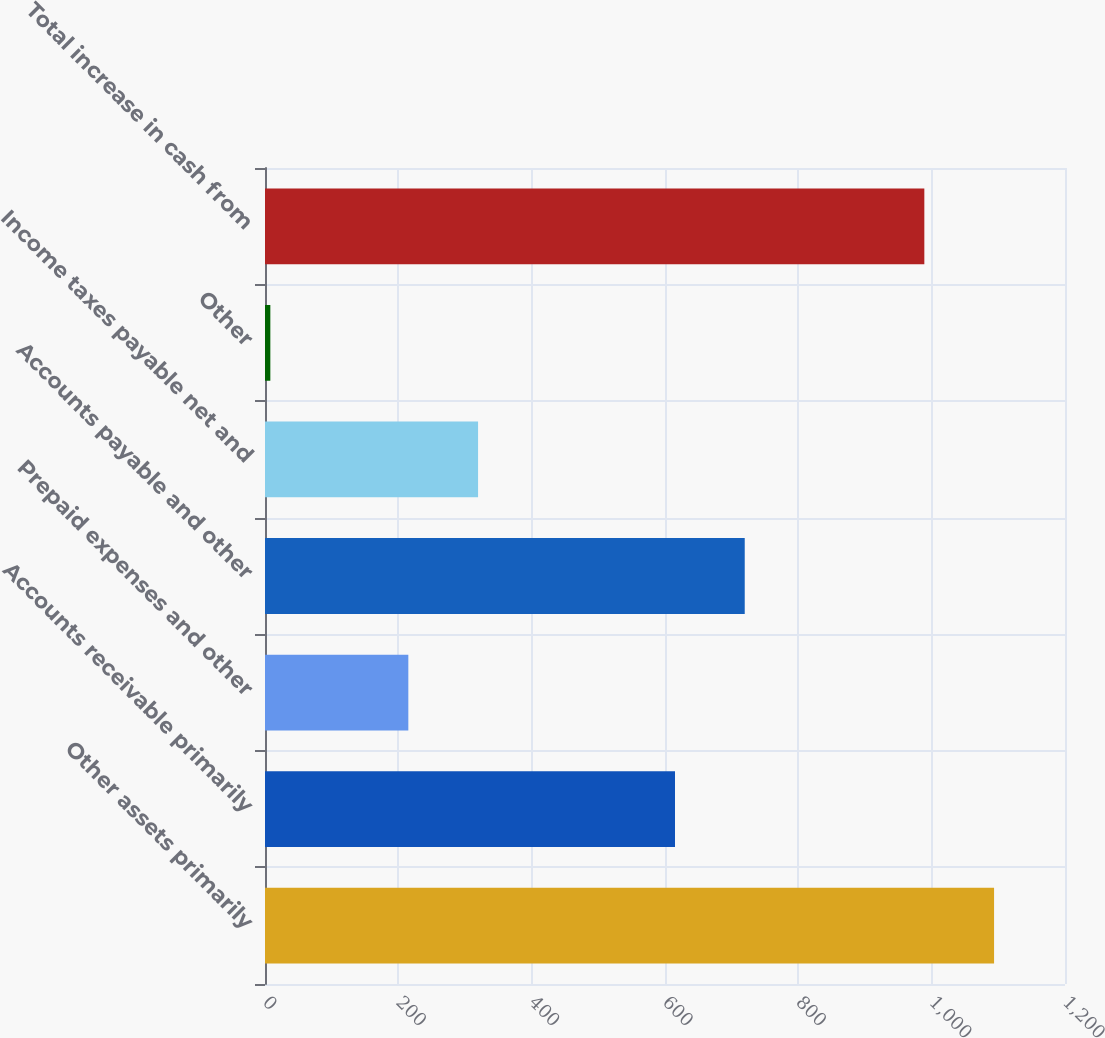Convert chart. <chart><loc_0><loc_0><loc_500><loc_500><bar_chart><fcel>Other assets primarily<fcel>Accounts receivable primarily<fcel>Prepaid expenses and other<fcel>Accounts payable and other<fcel>Income taxes payable net and<fcel>Other<fcel>Total increase in cash from<nl><fcel>1093.6<fcel>615<fcel>215<fcel>719.6<fcel>319.6<fcel>8<fcel>989<nl></chart> 